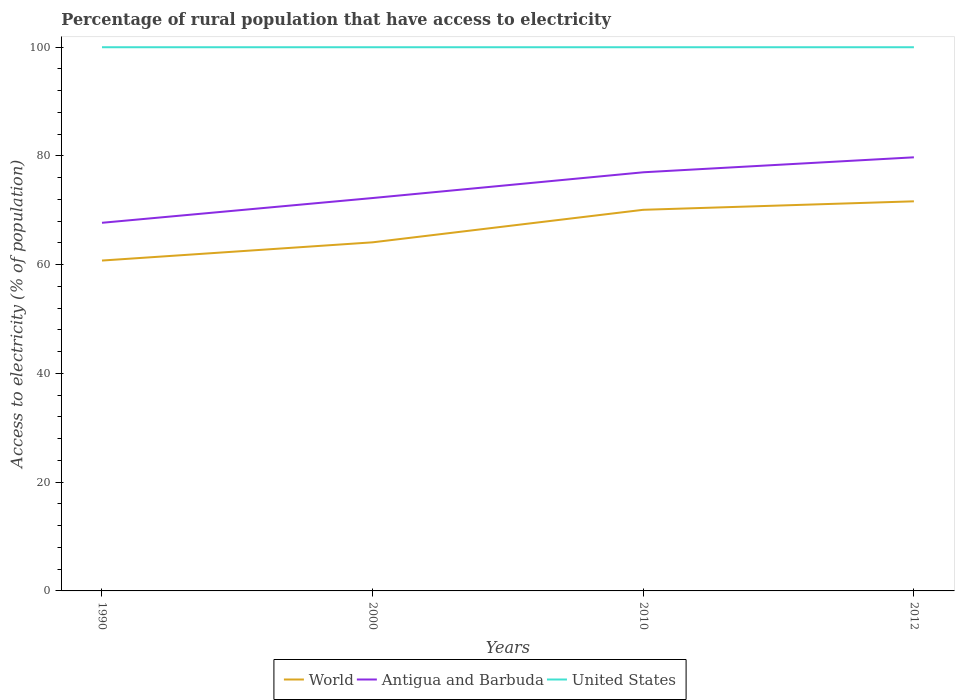How many different coloured lines are there?
Provide a short and direct response. 3. Is the number of lines equal to the number of legend labels?
Give a very brief answer. Yes. Across all years, what is the maximum percentage of rural population that have access to electricity in World?
Give a very brief answer. 60.77. In which year was the percentage of rural population that have access to electricity in World maximum?
Offer a very short reply. 1990. What is the total percentage of rural population that have access to electricity in World in the graph?
Offer a terse response. -3.35. What is the difference between the highest and the second highest percentage of rural population that have access to electricity in Antigua and Barbuda?
Make the answer very short. 12.04. What is the difference between the highest and the lowest percentage of rural population that have access to electricity in Antigua and Barbuda?
Provide a succinct answer. 2. Is the percentage of rural population that have access to electricity in United States strictly greater than the percentage of rural population that have access to electricity in Antigua and Barbuda over the years?
Offer a very short reply. No. How many years are there in the graph?
Ensure brevity in your answer.  4. What is the difference between two consecutive major ticks on the Y-axis?
Your response must be concise. 20. Does the graph contain any zero values?
Ensure brevity in your answer.  No. Does the graph contain grids?
Your response must be concise. No. Where does the legend appear in the graph?
Your response must be concise. Bottom center. What is the title of the graph?
Provide a short and direct response. Percentage of rural population that have access to electricity. What is the label or title of the X-axis?
Give a very brief answer. Years. What is the label or title of the Y-axis?
Ensure brevity in your answer.  Access to electricity (% of population). What is the Access to electricity (% of population) in World in 1990?
Provide a succinct answer. 60.77. What is the Access to electricity (% of population) of Antigua and Barbuda in 1990?
Your response must be concise. 67.71. What is the Access to electricity (% of population) in World in 2000?
Your response must be concise. 64.12. What is the Access to electricity (% of population) in Antigua and Barbuda in 2000?
Offer a terse response. 72.27. What is the Access to electricity (% of population) in World in 2010?
Your answer should be compact. 70.1. What is the Access to electricity (% of population) of United States in 2010?
Offer a very short reply. 100. What is the Access to electricity (% of population) in World in 2012?
Your response must be concise. 71.66. What is the Access to electricity (% of population) in Antigua and Barbuda in 2012?
Make the answer very short. 79.75. Across all years, what is the maximum Access to electricity (% of population) in World?
Your answer should be compact. 71.66. Across all years, what is the maximum Access to electricity (% of population) of Antigua and Barbuda?
Give a very brief answer. 79.75. Across all years, what is the maximum Access to electricity (% of population) in United States?
Provide a succinct answer. 100. Across all years, what is the minimum Access to electricity (% of population) of World?
Give a very brief answer. 60.77. Across all years, what is the minimum Access to electricity (% of population) of Antigua and Barbuda?
Offer a very short reply. 67.71. What is the total Access to electricity (% of population) of World in the graph?
Your answer should be compact. 266.65. What is the total Access to electricity (% of population) in Antigua and Barbuda in the graph?
Give a very brief answer. 296.73. What is the total Access to electricity (% of population) of United States in the graph?
Make the answer very short. 400. What is the difference between the Access to electricity (% of population) in World in 1990 and that in 2000?
Make the answer very short. -3.35. What is the difference between the Access to electricity (% of population) of Antigua and Barbuda in 1990 and that in 2000?
Offer a very short reply. -4.55. What is the difference between the Access to electricity (% of population) of World in 1990 and that in 2010?
Ensure brevity in your answer.  -9.34. What is the difference between the Access to electricity (% of population) in Antigua and Barbuda in 1990 and that in 2010?
Keep it short and to the point. -9.29. What is the difference between the Access to electricity (% of population) in World in 1990 and that in 2012?
Your answer should be very brief. -10.89. What is the difference between the Access to electricity (% of population) of Antigua and Barbuda in 1990 and that in 2012?
Provide a succinct answer. -12.04. What is the difference between the Access to electricity (% of population) of World in 2000 and that in 2010?
Provide a short and direct response. -5.98. What is the difference between the Access to electricity (% of population) of Antigua and Barbuda in 2000 and that in 2010?
Provide a succinct answer. -4.74. What is the difference between the Access to electricity (% of population) of World in 2000 and that in 2012?
Offer a very short reply. -7.54. What is the difference between the Access to electricity (% of population) of Antigua and Barbuda in 2000 and that in 2012?
Your answer should be very brief. -7.49. What is the difference between the Access to electricity (% of population) in World in 2010 and that in 2012?
Keep it short and to the point. -1.56. What is the difference between the Access to electricity (% of population) of Antigua and Barbuda in 2010 and that in 2012?
Your response must be concise. -2.75. What is the difference between the Access to electricity (% of population) in United States in 2010 and that in 2012?
Ensure brevity in your answer.  0. What is the difference between the Access to electricity (% of population) of World in 1990 and the Access to electricity (% of population) of Antigua and Barbuda in 2000?
Offer a terse response. -11.5. What is the difference between the Access to electricity (% of population) of World in 1990 and the Access to electricity (% of population) of United States in 2000?
Your answer should be very brief. -39.23. What is the difference between the Access to electricity (% of population) of Antigua and Barbuda in 1990 and the Access to electricity (% of population) of United States in 2000?
Provide a succinct answer. -32.29. What is the difference between the Access to electricity (% of population) in World in 1990 and the Access to electricity (% of population) in Antigua and Barbuda in 2010?
Provide a short and direct response. -16.23. What is the difference between the Access to electricity (% of population) in World in 1990 and the Access to electricity (% of population) in United States in 2010?
Provide a short and direct response. -39.23. What is the difference between the Access to electricity (% of population) in Antigua and Barbuda in 1990 and the Access to electricity (% of population) in United States in 2010?
Offer a very short reply. -32.29. What is the difference between the Access to electricity (% of population) of World in 1990 and the Access to electricity (% of population) of Antigua and Barbuda in 2012?
Offer a terse response. -18.99. What is the difference between the Access to electricity (% of population) in World in 1990 and the Access to electricity (% of population) in United States in 2012?
Keep it short and to the point. -39.23. What is the difference between the Access to electricity (% of population) of Antigua and Barbuda in 1990 and the Access to electricity (% of population) of United States in 2012?
Provide a succinct answer. -32.29. What is the difference between the Access to electricity (% of population) in World in 2000 and the Access to electricity (% of population) in Antigua and Barbuda in 2010?
Offer a very short reply. -12.88. What is the difference between the Access to electricity (% of population) of World in 2000 and the Access to electricity (% of population) of United States in 2010?
Your answer should be very brief. -35.88. What is the difference between the Access to electricity (% of population) in Antigua and Barbuda in 2000 and the Access to electricity (% of population) in United States in 2010?
Provide a succinct answer. -27.73. What is the difference between the Access to electricity (% of population) in World in 2000 and the Access to electricity (% of population) in Antigua and Barbuda in 2012?
Provide a short and direct response. -15.64. What is the difference between the Access to electricity (% of population) in World in 2000 and the Access to electricity (% of population) in United States in 2012?
Ensure brevity in your answer.  -35.88. What is the difference between the Access to electricity (% of population) in Antigua and Barbuda in 2000 and the Access to electricity (% of population) in United States in 2012?
Provide a short and direct response. -27.73. What is the difference between the Access to electricity (% of population) of World in 2010 and the Access to electricity (% of population) of Antigua and Barbuda in 2012?
Your answer should be very brief. -9.65. What is the difference between the Access to electricity (% of population) of World in 2010 and the Access to electricity (% of population) of United States in 2012?
Provide a succinct answer. -29.9. What is the average Access to electricity (% of population) of World per year?
Make the answer very short. 66.66. What is the average Access to electricity (% of population) in Antigua and Barbuda per year?
Provide a succinct answer. 74.18. In the year 1990, what is the difference between the Access to electricity (% of population) of World and Access to electricity (% of population) of Antigua and Barbuda?
Your response must be concise. -6.94. In the year 1990, what is the difference between the Access to electricity (% of population) of World and Access to electricity (% of population) of United States?
Provide a short and direct response. -39.23. In the year 1990, what is the difference between the Access to electricity (% of population) in Antigua and Barbuda and Access to electricity (% of population) in United States?
Provide a short and direct response. -32.29. In the year 2000, what is the difference between the Access to electricity (% of population) in World and Access to electricity (% of population) in Antigua and Barbuda?
Provide a succinct answer. -8.15. In the year 2000, what is the difference between the Access to electricity (% of population) in World and Access to electricity (% of population) in United States?
Offer a terse response. -35.88. In the year 2000, what is the difference between the Access to electricity (% of population) of Antigua and Barbuda and Access to electricity (% of population) of United States?
Offer a very short reply. -27.73. In the year 2010, what is the difference between the Access to electricity (% of population) in World and Access to electricity (% of population) in Antigua and Barbuda?
Ensure brevity in your answer.  -6.9. In the year 2010, what is the difference between the Access to electricity (% of population) of World and Access to electricity (% of population) of United States?
Provide a succinct answer. -29.9. In the year 2010, what is the difference between the Access to electricity (% of population) of Antigua and Barbuda and Access to electricity (% of population) of United States?
Provide a short and direct response. -23. In the year 2012, what is the difference between the Access to electricity (% of population) in World and Access to electricity (% of population) in Antigua and Barbuda?
Your answer should be compact. -8.09. In the year 2012, what is the difference between the Access to electricity (% of population) in World and Access to electricity (% of population) in United States?
Your answer should be compact. -28.34. In the year 2012, what is the difference between the Access to electricity (% of population) of Antigua and Barbuda and Access to electricity (% of population) of United States?
Your answer should be compact. -20.25. What is the ratio of the Access to electricity (% of population) of World in 1990 to that in 2000?
Your answer should be compact. 0.95. What is the ratio of the Access to electricity (% of population) of Antigua and Barbuda in 1990 to that in 2000?
Offer a very short reply. 0.94. What is the ratio of the Access to electricity (% of population) of World in 1990 to that in 2010?
Offer a terse response. 0.87. What is the ratio of the Access to electricity (% of population) in Antigua and Barbuda in 1990 to that in 2010?
Make the answer very short. 0.88. What is the ratio of the Access to electricity (% of population) in World in 1990 to that in 2012?
Give a very brief answer. 0.85. What is the ratio of the Access to electricity (% of population) of Antigua and Barbuda in 1990 to that in 2012?
Offer a very short reply. 0.85. What is the ratio of the Access to electricity (% of population) in World in 2000 to that in 2010?
Offer a very short reply. 0.91. What is the ratio of the Access to electricity (% of population) of Antigua and Barbuda in 2000 to that in 2010?
Provide a short and direct response. 0.94. What is the ratio of the Access to electricity (% of population) in World in 2000 to that in 2012?
Provide a succinct answer. 0.89. What is the ratio of the Access to electricity (% of population) of Antigua and Barbuda in 2000 to that in 2012?
Make the answer very short. 0.91. What is the ratio of the Access to electricity (% of population) in World in 2010 to that in 2012?
Offer a terse response. 0.98. What is the ratio of the Access to electricity (% of population) in Antigua and Barbuda in 2010 to that in 2012?
Ensure brevity in your answer.  0.97. What is the difference between the highest and the second highest Access to electricity (% of population) in World?
Your answer should be compact. 1.56. What is the difference between the highest and the second highest Access to electricity (% of population) of Antigua and Barbuda?
Keep it short and to the point. 2.75. What is the difference between the highest and the second highest Access to electricity (% of population) of United States?
Ensure brevity in your answer.  0. What is the difference between the highest and the lowest Access to electricity (% of population) in World?
Ensure brevity in your answer.  10.89. What is the difference between the highest and the lowest Access to electricity (% of population) of Antigua and Barbuda?
Offer a terse response. 12.04. 